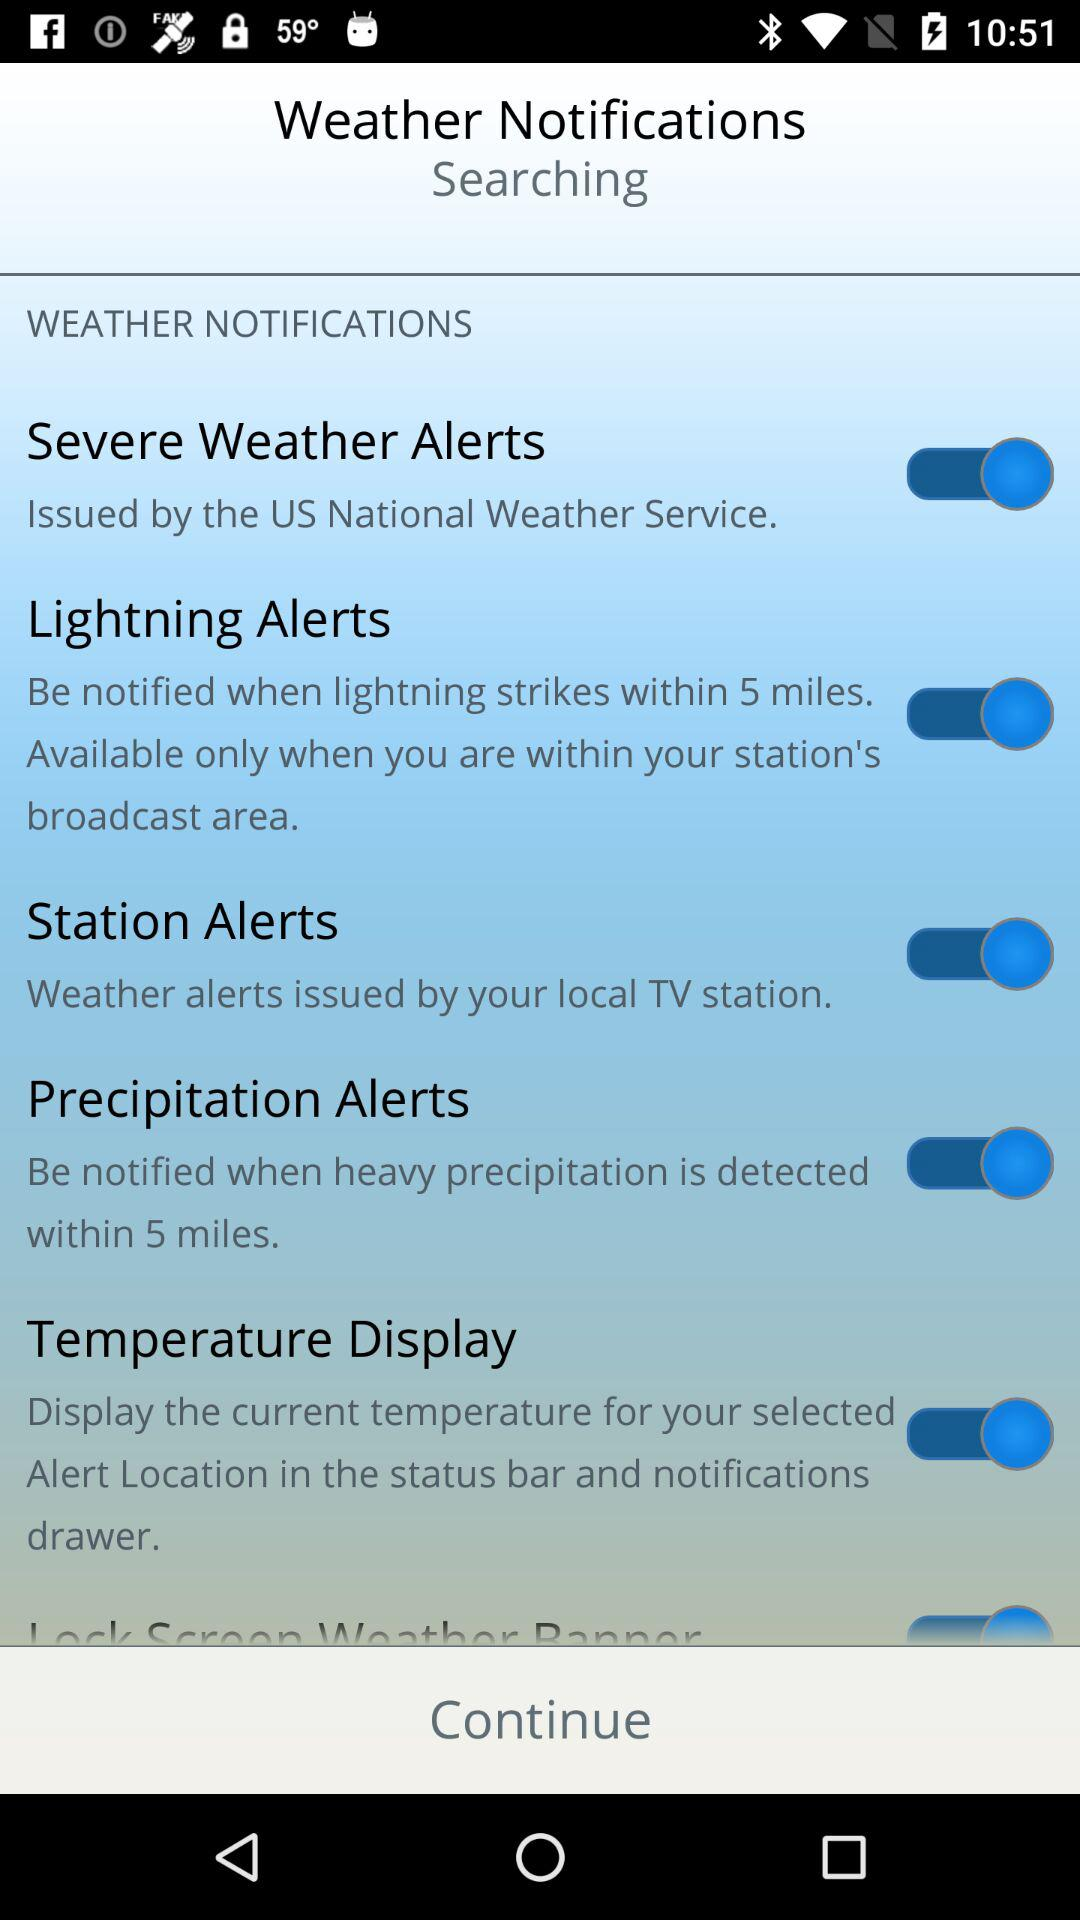What is the current status of the temperature display notification? The status is on. 